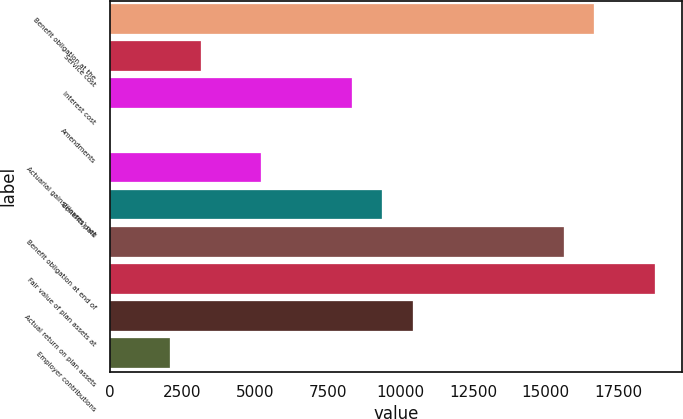Convert chart. <chart><loc_0><loc_0><loc_500><loc_500><bar_chart><fcel>Benefit obligation at the<fcel>Service cost<fcel>Interest cost<fcel>Amendments<fcel>Actuarial gains/(losses) net<fcel>Benefits paid<fcel>Benefit obligation at end of<fcel>Fair value of plan assets at<fcel>Actual return on plan assets<fcel>Employer contributions<nl><fcel>16663.2<fcel>3127.6<fcel>8333.6<fcel>4<fcel>5210<fcel>9374.8<fcel>15622<fcel>18745.6<fcel>10416<fcel>2086.4<nl></chart> 